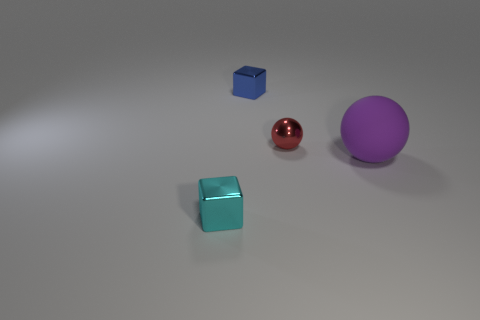Add 2 large matte things. How many objects exist? 6 Subtract all large objects. Subtract all tiny balls. How many objects are left? 2 Add 1 small things. How many small things are left? 4 Add 2 red rubber objects. How many red rubber objects exist? 2 Subtract 0 yellow blocks. How many objects are left? 4 